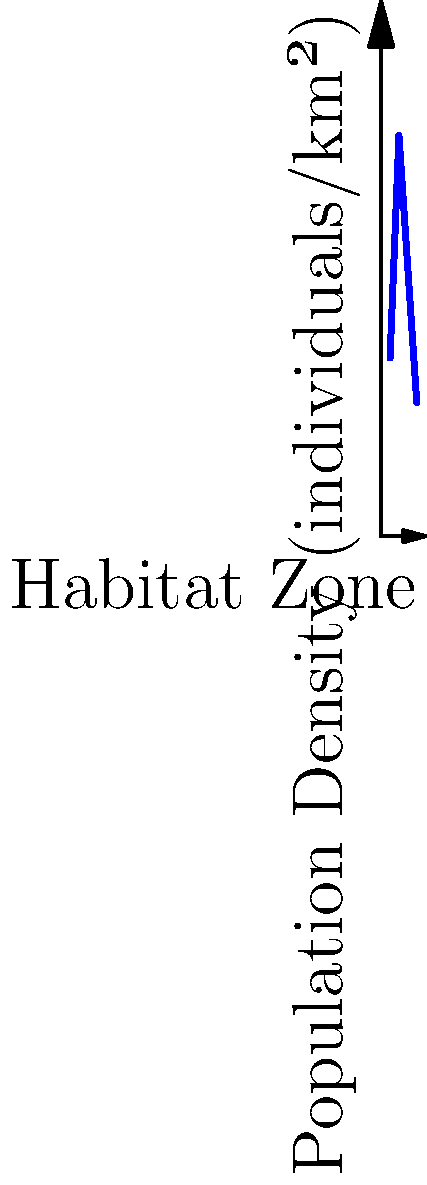Based on the graph showing small mammal population densities across different habitat zones, which habitat has the highest population density, and what is the approximate density value? To answer this question, we need to analyze the 2D coordinate system graph:

1. The x-axis represents different habitat zones: Forest (1), Grassland (2), Shrubland (3), and Wetland (4).
2. The y-axis represents the population density in individuals per square kilometer.
3. Each point on the graph corresponds to a specific habitat zone and its associated population density.
4. To find the highest population density, we need to identify the highest point on the graph.

Examining the graph:
- Forest (x=1) has a density of approximately 20 individuals/km²
- Grassland (x=2) has a density of approximately 45 individuals/km²
- Shrubland (x=3) has a density of approximately 30 individuals/km²
- Wetland (x=4) has a density of approximately 15 individuals/km²

The highest point on the graph corresponds to the Grassland habitat (x=2), with a population density of about 45 individuals/km².
Answer: Grassland, 45 individuals/km² 